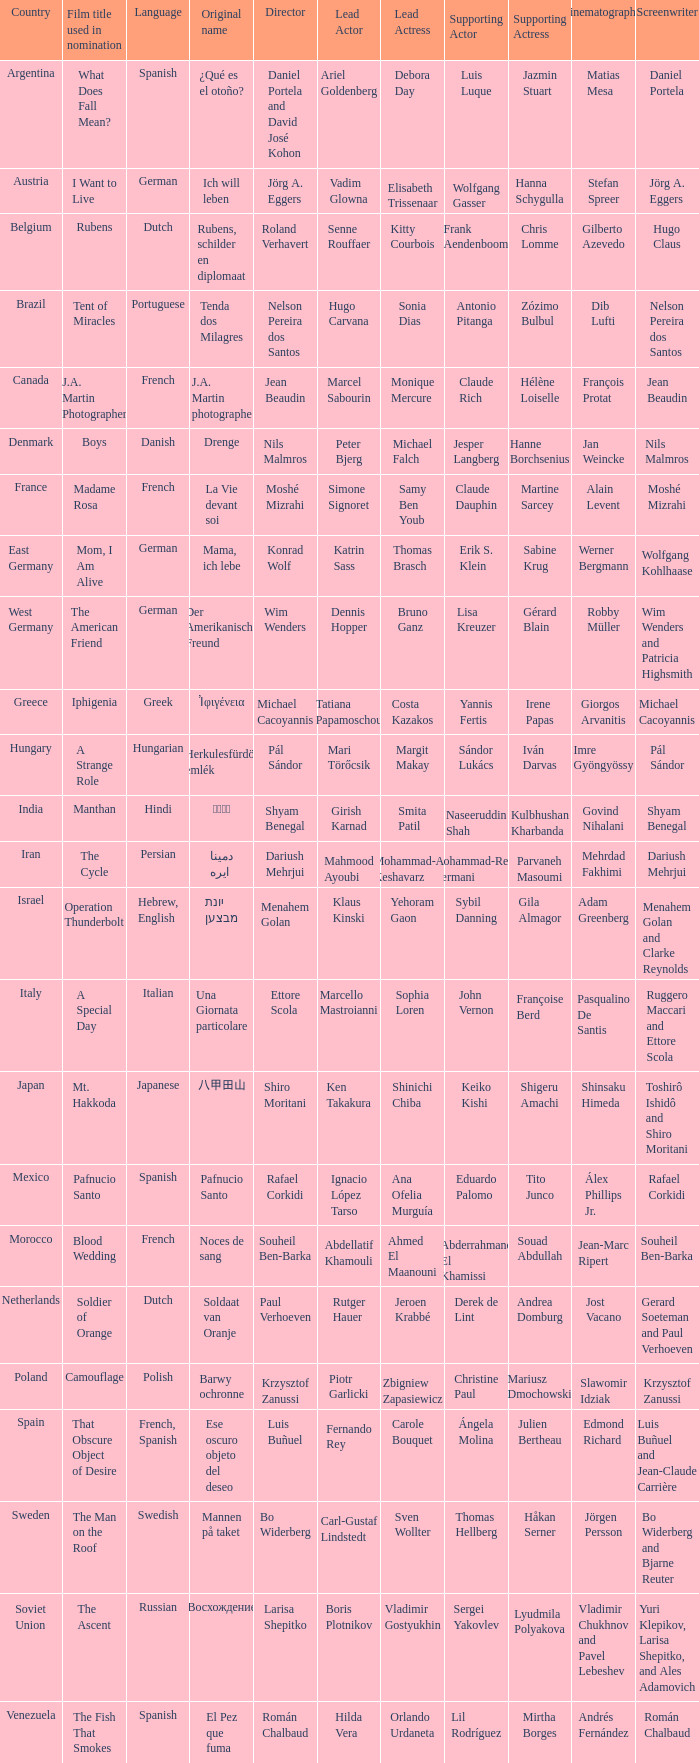Give me the full table as a dictionary. {'header': ['Country', 'Film title used in nomination', 'Language', 'Original name', 'Director', 'Lead Actor', 'Lead Actress', 'Supporting Actor', 'Supporting Actress', 'Cinematographer', 'Screenwriter'], 'rows': [['Argentina', 'What Does Fall Mean?', 'Spanish', '¿Qué es el otoño?', 'Daniel Portela and David José Kohon', 'Ariel Goldenberg', 'Debora Day', 'Luis Luque', 'Jazmin Stuart', 'Matias Mesa', 'Daniel Portela'], ['Austria', 'I Want to Live', 'German', 'Ich will leben', 'Jörg A. Eggers', 'Vadim Glowna', 'Elisabeth Trissenaar', 'Wolfgang Gasser', 'Hanna Schygulla', 'Stefan Spreer', 'Jörg A. Eggers'], ['Belgium', 'Rubens', 'Dutch', 'Rubens, schilder en diplomaat', 'Roland Verhavert', 'Senne Rouffaer', 'Kitty Courbois', 'Frank Aendenboom', 'Chris Lomme', 'Gilberto Azevedo', 'Hugo Claus'], ['Brazil', 'Tent of Miracles', 'Portuguese', 'Tenda dos Milagres', 'Nelson Pereira dos Santos', 'Hugo Carvana', 'Sonia Dias', 'Antonio Pitanga', 'Zózimo Bulbul', 'Dib Lufti', 'Nelson Pereira dos Santos'], ['Canada', 'J.A. Martin Photographer', 'French', 'J.A. Martin photographe', 'Jean Beaudin', 'Marcel Sabourin', 'Monique Mercure', 'Claude Rich', 'Hélène Loiselle', 'François Protat', 'Jean Beaudin'], ['Denmark', 'Boys', 'Danish', 'Drenge', 'Nils Malmros', 'Peter Bjerg', 'Michael Falch', 'Jesper Langberg', 'Hanne Borchsenius', 'Jan Weincke', 'Nils Malmros'], ['France', 'Madame Rosa', 'French', 'La Vie devant soi', 'Moshé Mizrahi', 'Simone Signoret', 'Samy Ben Youb', 'Claude Dauphin', 'Martine Sarcey', 'Alain Levent', 'Moshé Mizrahi'], ['East Germany', 'Mom, I Am Alive', 'German', 'Mama, ich lebe', 'Konrad Wolf', 'Katrin Sass', 'Thomas Brasch', 'Erik S. Klein', 'Sabine Krug', 'Werner Bergmann', 'Wolfgang Kohlhaase'], ['West Germany', 'The American Friend', 'German', 'Der Amerikanische Freund', 'Wim Wenders', 'Dennis Hopper', 'Bruno Ganz', 'Lisa Kreuzer', 'Gérard Blain', 'Robby Müller', 'Wim Wenders and Patricia Highsmith'], ['Greece', 'Iphigenia', 'Greek', 'Ἰφιγένεια', 'Michael Cacoyannis', 'Tatiana Papamoschou', 'Costa Kazakos', 'Yannis Fertis', 'Irene Papas', 'Giorgos Arvanitis', 'Michael Cacoyannis'], ['Hungary', 'A Strange Role', 'Hungarian', 'Herkulesfürdöi emlék', 'Pál Sándor', 'Mari Törőcsik', 'Margit Makay', 'Sándor Lukács', 'Iván Darvas', 'Imre Gyöngyössy', 'Pál Sándor'], ['India', 'Manthan', 'Hindi', 'मंथन', 'Shyam Benegal', 'Girish Karnad', 'Smita Patil', 'Naseeruddin Shah', 'Kulbhushan Kharbanda', 'Govind Nihalani', 'Shyam Benegal'], ['Iran', 'The Cycle', 'Persian', 'دايره مينا', 'Dariush Mehrjui', 'Mahmood Ayoubi', 'Mohammad-Ali Keshavarz', 'Mohammad-Reza Kermani', 'Parvaneh Masoumi', 'Mehrdad Fakhimi', 'Dariush Mehrjui'], ['Israel', 'Operation Thunderbolt', 'Hebrew, English', 'מבצע יונתן', 'Menahem Golan', 'Klaus Kinski', 'Yehoram Gaon', 'Sybil Danning', 'Gila Almagor', 'Adam Greenberg', 'Menahem Golan and Clarke Reynolds'], ['Italy', 'A Special Day', 'Italian', 'Una Giornata particolare', 'Ettore Scola', 'Marcello Mastroianni', 'Sophia Loren', 'John Vernon', 'Françoise Berd', 'Pasqualino De Santis', 'Ruggero Maccari and Ettore Scola'], ['Japan', 'Mt. Hakkoda', 'Japanese', '八甲田山', 'Shiro Moritani', 'Ken Takakura', 'Shinichi Chiba', 'Keiko Kishi', 'Shigeru Amachi', 'Shinsaku Himeda', 'Toshirô Ishidô and Shiro Moritani'], ['Mexico', 'Pafnucio Santo', 'Spanish', 'Pafnucio Santo', 'Rafael Corkidi', 'Ignacio López Tarso', 'Ana Ofelia Murguía', 'Eduardo Palomo', 'Tito Junco', 'Álex Phillips Jr.', 'Rafael Corkidi'], ['Morocco', 'Blood Wedding', 'French', 'Noces de sang', 'Souheil Ben-Barka', 'Abdellatif Khamouli', 'Ahmed El Maanouni', 'Abderrahmane El Khamissi', 'Souad Abdullah', 'Jean-Marc Ripert', 'Souheil Ben-Barka'], ['Netherlands', 'Soldier of Orange', 'Dutch', 'Soldaat van Oranje', 'Paul Verhoeven', 'Rutger Hauer', 'Jeroen Krabbé', 'Derek de Lint', 'Andrea Domburg', 'Jost Vacano', 'Gerard Soeteman and Paul Verhoeven'], ['Poland', 'Camouflage', 'Polish', 'Barwy ochronne', 'Krzysztof Zanussi', 'Piotr Garlicki', 'Zbigniew Zapasiewicz', 'Christine Paul', 'Mariusz Dmochowski', 'Slawomir Idziak', 'Krzysztof Zanussi'], ['Spain', 'That Obscure Object of Desire', 'French, Spanish', 'Ese oscuro objeto del deseo', 'Luis Buñuel', 'Fernando Rey', 'Carole Bouquet', 'Ángela Molina', 'Julien Bertheau', 'Edmond Richard', 'Luis Buñuel and Jean-Claude Carrière'], ['Sweden', 'The Man on the Roof', 'Swedish', 'Mannen på taket', 'Bo Widerberg', 'Carl-Gustaf Lindstedt', 'Sven Wollter', 'Thomas Hellberg', 'Håkan Serner', 'Jörgen Persson', 'Bo Widerberg and Bjarne Reuter'], ['Soviet Union', 'The Ascent', 'Russian', 'Восхождение', 'Larisa Shepitko', 'Boris Plotnikov', 'Vladimir Gostyukhin', 'Sergei Yakovlev', 'Lyudmila Polyakova', 'Vladimir Chukhnov and Pavel Lebeshev', 'Yuri Klepikov, Larisa Shepitko, and Ales Adamovich'], ['Venezuela', 'The Fish That Smokes', 'Spanish', 'El Pez que fuma', 'Román Chalbaud', 'Hilda Vera', 'Orlando Urdaneta', 'Lil Rodríguez', 'Mirtha Borges', 'Andrés Fernández', 'Román Chalbaud']]} Which country is the director Roland Verhavert from? Belgium. 